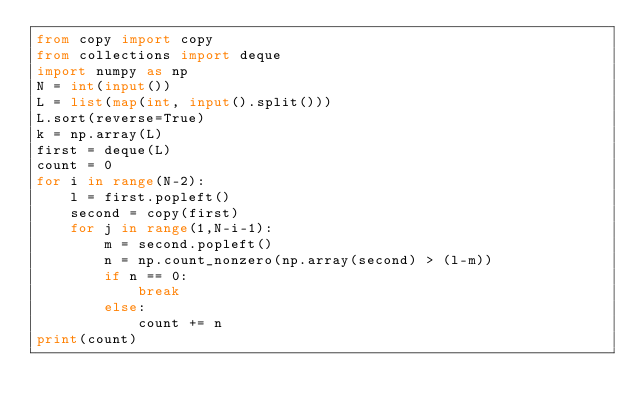<code> <loc_0><loc_0><loc_500><loc_500><_Python_>from copy import copy
from collections import deque
import numpy as np
N = int(input())
L = list(map(int, input().split()))
L.sort(reverse=True)
k = np.array(L)
first = deque(L)
count = 0
for i in range(N-2):
    l = first.popleft()
    second = copy(first)
    for j in range(1,N-i-1):
        m = second.popleft()
        n = np.count_nonzero(np.array(second) > (l-m))
        if n == 0:
            break
        else:
            count += n
print(count)</code> 